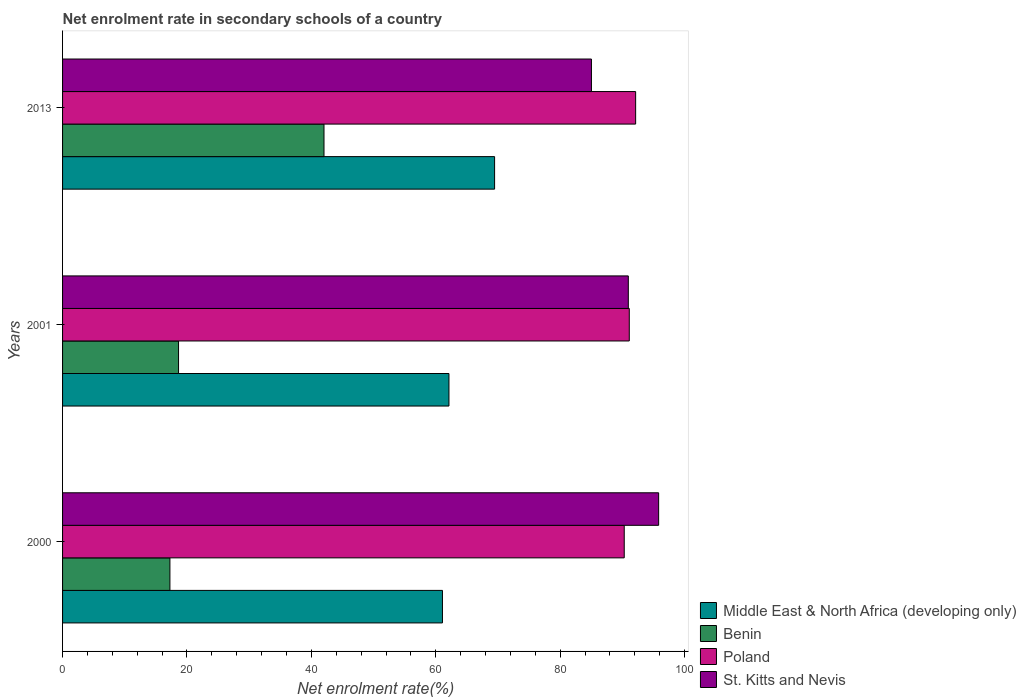How many groups of bars are there?
Provide a short and direct response. 3. Are the number of bars per tick equal to the number of legend labels?
Provide a succinct answer. Yes. How many bars are there on the 1st tick from the bottom?
Provide a succinct answer. 4. What is the label of the 3rd group of bars from the top?
Ensure brevity in your answer.  2000. What is the net enrolment rate in secondary schools in St. Kitts and Nevis in 2000?
Give a very brief answer. 95.83. Across all years, what is the maximum net enrolment rate in secondary schools in Poland?
Offer a terse response. 92.13. Across all years, what is the minimum net enrolment rate in secondary schools in Benin?
Offer a terse response. 17.26. In which year was the net enrolment rate in secondary schools in St. Kitts and Nevis minimum?
Make the answer very short. 2013. What is the total net enrolment rate in secondary schools in Middle East & North Africa (developing only) in the graph?
Your answer should be very brief. 192.65. What is the difference between the net enrolment rate in secondary schools in St. Kitts and Nevis in 2000 and that in 2013?
Ensure brevity in your answer.  10.8. What is the difference between the net enrolment rate in secondary schools in Poland in 2013 and the net enrolment rate in secondary schools in Middle East & North Africa (developing only) in 2001?
Your answer should be compact. 30.01. What is the average net enrolment rate in secondary schools in St. Kitts and Nevis per year?
Your answer should be compact. 90.6. In the year 2001, what is the difference between the net enrolment rate in secondary schools in Benin and net enrolment rate in secondary schools in Poland?
Make the answer very short. -72.46. In how many years, is the net enrolment rate in secondary schools in Benin greater than 68 %?
Your answer should be very brief. 0. What is the ratio of the net enrolment rate in secondary schools in Middle East & North Africa (developing only) in 2000 to that in 2013?
Your answer should be very brief. 0.88. Is the net enrolment rate in secondary schools in Benin in 2001 less than that in 2013?
Your response must be concise. Yes. What is the difference between the highest and the second highest net enrolment rate in secondary schools in Benin?
Your answer should be compact. 23.38. What is the difference between the highest and the lowest net enrolment rate in secondary schools in Middle East & North Africa (developing only)?
Your response must be concise. 8.38. Is the sum of the net enrolment rate in secondary schools in Middle East & North Africa (developing only) in 2000 and 2001 greater than the maximum net enrolment rate in secondary schools in Poland across all years?
Provide a succinct answer. Yes. What does the 1st bar from the bottom in 2001 represents?
Provide a short and direct response. Middle East & North Africa (developing only). Is it the case that in every year, the sum of the net enrolment rate in secondary schools in Benin and net enrolment rate in secondary schools in Poland is greater than the net enrolment rate in secondary schools in St. Kitts and Nevis?
Your answer should be compact. Yes. How many bars are there?
Provide a succinct answer. 12. Are all the bars in the graph horizontal?
Give a very brief answer. Yes. How many years are there in the graph?
Provide a succinct answer. 3. What is the difference between two consecutive major ticks on the X-axis?
Offer a terse response. 20. Does the graph contain any zero values?
Give a very brief answer. No. Does the graph contain grids?
Your response must be concise. No. How many legend labels are there?
Give a very brief answer. 4. How are the legend labels stacked?
Your answer should be compact. Vertical. What is the title of the graph?
Give a very brief answer. Net enrolment rate in secondary schools of a country. What is the label or title of the X-axis?
Your answer should be compact. Net enrolment rate(%). What is the label or title of the Y-axis?
Give a very brief answer. Years. What is the Net enrolment rate(%) in Middle East & North Africa (developing only) in 2000?
Offer a very short reply. 61.07. What is the Net enrolment rate(%) in Benin in 2000?
Ensure brevity in your answer.  17.26. What is the Net enrolment rate(%) in Poland in 2000?
Offer a terse response. 90.3. What is the Net enrolment rate(%) of St. Kitts and Nevis in 2000?
Your answer should be very brief. 95.83. What is the Net enrolment rate(%) of Middle East & North Africa (developing only) in 2001?
Give a very brief answer. 62.12. What is the Net enrolment rate(%) in Benin in 2001?
Provide a short and direct response. 18.65. What is the Net enrolment rate(%) of Poland in 2001?
Your answer should be compact. 91.11. What is the Net enrolment rate(%) of St. Kitts and Nevis in 2001?
Make the answer very short. 90.95. What is the Net enrolment rate(%) in Middle East & North Africa (developing only) in 2013?
Offer a terse response. 69.46. What is the Net enrolment rate(%) of Benin in 2013?
Provide a short and direct response. 42.03. What is the Net enrolment rate(%) of Poland in 2013?
Offer a very short reply. 92.13. What is the Net enrolment rate(%) in St. Kitts and Nevis in 2013?
Make the answer very short. 85.03. Across all years, what is the maximum Net enrolment rate(%) of Middle East & North Africa (developing only)?
Provide a short and direct response. 69.46. Across all years, what is the maximum Net enrolment rate(%) in Benin?
Your response must be concise. 42.03. Across all years, what is the maximum Net enrolment rate(%) of Poland?
Your answer should be compact. 92.13. Across all years, what is the maximum Net enrolment rate(%) in St. Kitts and Nevis?
Provide a succinct answer. 95.83. Across all years, what is the minimum Net enrolment rate(%) in Middle East & North Africa (developing only)?
Offer a terse response. 61.07. Across all years, what is the minimum Net enrolment rate(%) of Benin?
Offer a very short reply. 17.26. Across all years, what is the minimum Net enrolment rate(%) of Poland?
Your answer should be compact. 90.3. Across all years, what is the minimum Net enrolment rate(%) in St. Kitts and Nevis?
Your answer should be very brief. 85.03. What is the total Net enrolment rate(%) of Middle East & North Africa (developing only) in the graph?
Your answer should be very brief. 192.65. What is the total Net enrolment rate(%) in Benin in the graph?
Make the answer very short. 77.93. What is the total Net enrolment rate(%) in Poland in the graph?
Ensure brevity in your answer.  273.54. What is the total Net enrolment rate(%) in St. Kitts and Nevis in the graph?
Ensure brevity in your answer.  271.81. What is the difference between the Net enrolment rate(%) of Middle East & North Africa (developing only) in 2000 and that in 2001?
Keep it short and to the point. -1.04. What is the difference between the Net enrolment rate(%) in Benin in 2000 and that in 2001?
Your response must be concise. -1.39. What is the difference between the Net enrolment rate(%) of Poland in 2000 and that in 2001?
Your answer should be very brief. -0.81. What is the difference between the Net enrolment rate(%) of St. Kitts and Nevis in 2000 and that in 2001?
Offer a very short reply. 4.88. What is the difference between the Net enrolment rate(%) in Middle East & North Africa (developing only) in 2000 and that in 2013?
Make the answer very short. -8.38. What is the difference between the Net enrolment rate(%) of Benin in 2000 and that in 2013?
Offer a terse response. -24.77. What is the difference between the Net enrolment rate(%) of Poland in 2000 and that in 2013?
Provide a short and direct response. -1.83. What is the difference between the Net enrolment rate(%) in St. Kitts and Nevis in 2000 and that in 2013?
Give a very brief answer. 10.8. What is the difference between the Net enrolment rate(%) in Middle East & North Africa (developing only) in 2001 and that in 2013?
Give a very brief answer. -7.34. What is the difference between the Net enrolment rate(%) of Benin in 2001 and that in 2013?
Offer a terse response. -23.38. What is the difference between the Net enrolment rate(%) in Poland in 2001 and that in 2013?
Keep it short and to the point. -1.02. What is the difference between the Net enrolment rate(%) of St. Kitts and Nevis in 2001 and that in 2013?
Make the answer very short. 5.93. What is the difference between the Net enrolment rate(%) of Middle East & North Africa (developing only) in 2000 and the Net enrolment rate(%) of Benin in 2001?
Your response must be concise. 42.43. What is the difference between the Net enrolment rate(%) of Middle East & North Africa (developing only) in 2000 and the Net enrolment rate(%) of Poland in 2001?
Your answer should be very brief. -30.04. What is the difference between the Net enrolment rate(%) of Middle East & North Africa (developing only) in 2000 and the Net enrolment rate(%) of St. Kitts and Nevis in 2001?
Give a very brief answer. -29.88. What is the difference between the Net enrolment rate(%) of Benin in 2000 and the Net enrolment rate(%) of Poland in 2001?
Offer a terse response. -73.85. What is the difference between the Net enrolment rate(%) in Benin in 2000 and the Net enrolment rate(%) in St. Kitts and Nevis in 2001?
Provide a short and direct response. -73.7. What is the difference between the Net enrolment rate(%) of Poland in 2000 and the Net enrolment rate(%) of St. Kitts and Nevis in 2001?
Provide a short and direct response. -0.66. What is the difference between the Net enrolment rate(%) in Middle East & North Africa (developing only) in 2000 and the Net enrolment rate(%) in Benin in 2013?
Your answer should be compact. 19.04. What is the difference between the Net enrolment rate(%) of Middle East & North Africa (developing only) in 2000 and the Net enrolment rate(%) of Poland in 2013?
Your response must be concise. -31.06. What is the difference between the Net enrolment rate(%) in Middle East & North Africa (developing only) in 2000 and the Net enrolment rate(%) in St. Kitts and Nevis in 2013?
Provide a succinct answer. -23.95. What is the difference between the Net enrolment rate(%) in Benin in 2000 and the Net enrolment rate(%) in Poland in 2013?
Ensure brevity in your answer.  -74.87. What is the difference between the Net enrolment rate(%) of Benin in 2000 and the Net enrolment rate(%) of St. Kitts and Nevis in 2013?
Ensure brevity in your answer.  -67.77. What is the difference between the Net enrolment rate(%) of Poland in 2000 and the Net enrolment rate(%) of St. Kitts and Nevis in 2013?
Offer a terse response. 5.27. What is the difference between the Net enrolment rate(%) of Middle East & North Africa (developing only) in 2001 and the Net enrolment rate(%) of Benin in 2013?
Your answer should be compact. 20.09. What is the difference between the Net enrolment rate(%) in Middle East & North Africa (developing only) in 2001 and the Net enrolment rate(%) in Poland in 2013?
Provide a short and direct response. -30.01. What is the difference between the Net enrolment rate(%) of Middle East & North Africa (developing only) in 2001 and the Net enrolment rate(%) of St. Kitts and Nevis in 2013?
Provide a short and direct response. -22.91. What is the difference between the Net enrolment rate(%) of Benin in 2001 and the Net enrolment rate(%) of Poland in 2013?
Offer a very short reply. -73.49. What is the difference between the Net enrolment rate(%) of Benin in 2001 and the Net enrolment rate(%) of St. Kitts and Nevis in 2013?
Your answer should be very brief. -66.38. What is the difference between the Net enrolment rate(%) in Poland in 2001 and the Net enrolment rate(%) in St. Kitts and Nevis in 2013?
Give a very brief answer. 6.08. What is the average Net enrolment rate(%) in Middle East & North Africa (developing only) per year?
Your answer should be compact. 64.22. What is the average Net enrolment rate(%) in Benin per year?
Keep it short and to the point. 25.98. What is the average Net enrolment rate(%) of Poland per year?
Give a very brief answer. 91.18. What is the average Net enrolment rate(%) in St. Kitts and Nevis per year?
Provide a succinct answer. 90.6. In the year 2000, what is the difference between the Net enrolment rate(%) of Middle East & North Africa (developing only) and Net enrolment rate(%) of Benin?
Offer a very short reply. 43.82. In the year 2000, what is the difference between the Net enrolment rate(%) in Middle East & North Africa (developing only) and Net enrolment rate(%) in Poland?
Offer a very short reply. -29.22. In the year 2000, what is the difference between the Net enrolment rate(%) in Middle East & North Africa (developing only) and Net enrolment rate(%) in St. Kitts and Nevis?
Your answer should be very brief. -34.75. In the year 2000, what is the difference between the Net enrolment rate(%) in Benin and Net enrolment rate(%) in Poland?
Provide a short and direct response. -73.04. In the year 2000, what is the difference between the Net enrolment rate(%) in Benin and Net enrolment rate(%) in St. Kitts and Nevis?
Ensure brevity in your answer.  -78.57. In the year 2000, what is the difference between the Net enrolment rate(%) in Poland and Net enrolment rate(%) in St. Kitts and Nevis?
Ensure brevity in your answer.  -5.53. In the year 2001, what is the difference between the Net enrolment rate(%) in Middle East & North Africa (developing only) and Net enrolment rate(%) in Benin?
Offer a very short reply. 43.47. In the year 2001, what is the difference between the Net enrolment rate(%) of Middle East & North Africa (developing only) and Net enrolment rate(%) of Poland?
Ensure brevity in your answer.  -28.99. In the year 2001, what is the difference between the Net enrolment rate(%) in Middle East & North Africa (developing only) and Net enrolment rate(%) in St. Kitts and Nevis?
Provide a succinct answer. -28.83. In the year 2001, what is the difference between the Net enrolment rate(%) in Benin and Net enrolment rate(%) in Poland?
Your response must be concise. -72.46. In the year 2001, what is the difference between the Net enrolment rate(%) of Benin and Net enrolment rate(%) of St. Kitts and Nevis?
Your answer should be compact. -72.31. In the year 2001, what is the difference between the Net enrolment rate(%) of Poland and Net enrolment rate(%) of St. Kitts and Nevis?
Ensure brevity in your answer.  0.16. In the year 2013, what is the difference between the Net enrolment rate(%) of Middle East & North Africa (developing only) and Net enrolment rate(%) of Benin?
Keep it short and to the point. 27.43. In the year 2013, what is the difference between the Net enrolment rate(%) in Middle East & North Africa (developing only) and Net enrolment rate(%) in Poland?
Give a very brief answer. -22.68. In the year 2013, what is the difference between the Net enrolment rate(%) in Middle East & North Africa (developing only) and Net enrolment rate(%) in St. Kitts and Nevis?
Provide a short and direct response. -15.57. In the year 2013, what is the difference between the Net enrolment rate(%) of Benin and Net enrolment rate(%) of Poland?
Give a very brief answer. -50.1. In the year 2013, what is the difference between the Net enrolment rate(%) in Benin and Net enrolment rate(%) in St. Kitts and Nevis?
Your answer should be compact. -43. In the year 2013, what is the difference between the Net enrolment rate(%) in Poland and Net enrolment rate(%) in St. Kitts and Nevis?
Provide a short and direct response. 7.11. What is the ratio of the Net enrolment rate(%) of Middle East & North Africa (developing only) in 2000 to that in 2001?
Give a very brief answer. 0.98. What is the ratio of the Net enrolment rate(%) of Benin in 2000 to that in 2001?
Ensure brevity in your answer.  0.93. What is the ratio of the Net enrolment rate(%) of St. Kitts and Nevis in 2000 to that in 2001?
Offer a very short reply. 1.05. What is the ratio of the Net enrolment rate(%) in Middle East & North Africa (developing only) in 2000 to that in 2013?
Your answer should be compact. 0.88. What is the ratio of the Net enrolment rate(%) of Benin in 2000 to that in 2013?
Ensure brevity in your answer.  0.41. What is the ratio of the Net enrolment rate(%) in Poland in 2000 to that in 2013?
Make the answer very short. 0.98. What is the ratio of the Net enrolment rate(%) of St. Kitts and Nevis in 2000 to that in 2013?
Your answer should be very brief. 1.13. What is the ratio of the Net enrolment rate(%) in Middle East & North Africa (developing only) in 2001 to that in 2013?
Ensure brevity in your answer.  0.89. What is the ratio of the Net enrolment rate(%) of Benin in 2001 to that in 2013?
Ensure brevity in your answer.  0.44. What is the ratio of the Net enrolment rate(%) of Poland in 2001 to that in 2013?
Provide a short and direct response. 0.99. What is the ratio of the Net enrolment rate(%) of St. Kitts and Nevis in 2001 to that in 2013?
Offer a terse response. 1.07. What is the difference between the highest and the second highest Net enrolment rate(%) in Middle East & North Africa (developing only)?
Offer a very short reply. 7.34. What is the difference between the highest and the second highest Net enrolment rate(%) in Benin?
Your answer should be very brief. 23.38. What is the difference between the highest and the second highest Net enrolment rate(%) in St. Kitts and Nevis?
Your answer should be compact. 4.88. What is the difference between the highest and the lowest Net enrolment rate(%) in Middle East & North Africa (developing only)?
Your answer should be compact. 8.38. What is the difference between the highest and the lowest Net enrolment rate(%) of Benin?
Offer a very short reply. 24.77. What is the difference between the highest and the lowest Net enrolment rate(%) of Poland?
Offer a terse response. 1.83. What is the difference between the highest and the lowest Net enrolment rate(%) of St. Kitts and Nevis?
Your response must be concise. 10.8. 